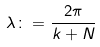<formula> <loc_0><loc_0><loc_500><loc_500>\lambda \colon = \frac { 2 \pi } { k + N }</formula> 